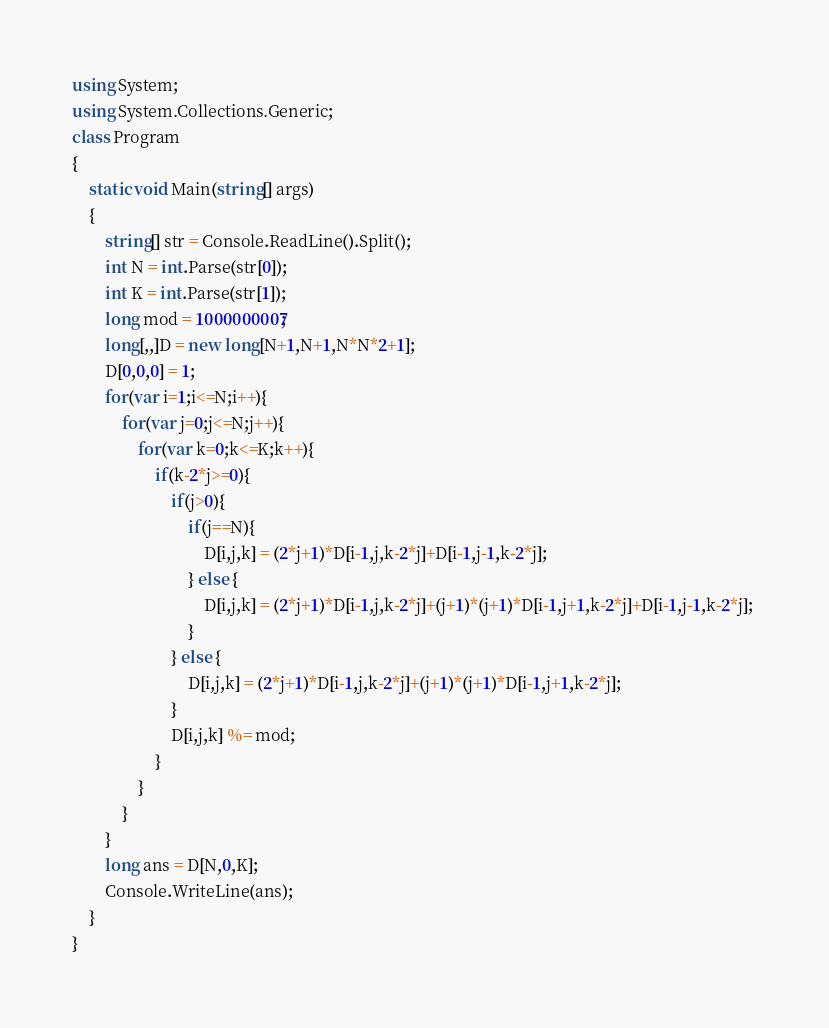<code> <loc_0><loc_0><loc_500><loc_500><_C#_>using System;
using System.Collections.Generic;
class Program
{
	static void Main(string[] args)
	{
		string[] str = Console.ReadLine().Split();
		int N = int.Parse(str[0]);
		int K = int.Parse(str[1]);
		long mod = 1000000007;
		long[,,]D = new long[N+1,N+1,N*N*2+1];
		D[0,0,0] = 1;
		for(var i=1;i<=N;i++){
			for(var j=0;j<=N;j++){
				for(var k=0;k<=K;k++){
                  	if(k-2*j>=0){
                      	if(j>0){
                          	if(j==N){
	                          	D[i,j,k] = (2*j+1)*D[i-1,j,k-2*j]+D[i-1,j-1,k-2*j]; 
                            } else {
                              	D[i,j,k] = (2*j+1)*D[i-1,j,k-2*j]+(j+1)*(j+1)*D[i-1,j+1,k-2*j]+D[i-1,j-1,k-2*j]; 
                            }
                        } else {
                         	D[i,j,k] = (2*j+1)*D[i-1,j,k-2*j]+(j+1)*(j+1)*D[i-1,j+1,k-2*j];
                        }
                    	D[i,j,k] %= mod;
                    }
				}
			}
		}
		long ans = D[N,0,K];
		Console.WriteLine(ans);
	}
}</code> 